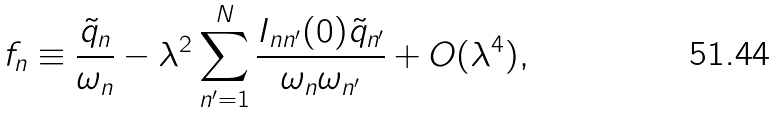Convert formula to latex. <formula><loc_0><loc_0><loc_500><loc_500>f _ { n } \equiv \frac { \tilde { q } _ { n } } { \omega _ { n } } - \lambda ^ { 2 } \sum _ { n ^ { \prime } = 1 } ^ { N } \frac { I _ { n n ^ { \prime } } ( 0 ) \tilde { q } _ { n ^ { \prime } } } { \omega _ { n } \omega _ { n ^ { \prime } } } + O ( \lambda ^ { 4 } ) ,</formula> 